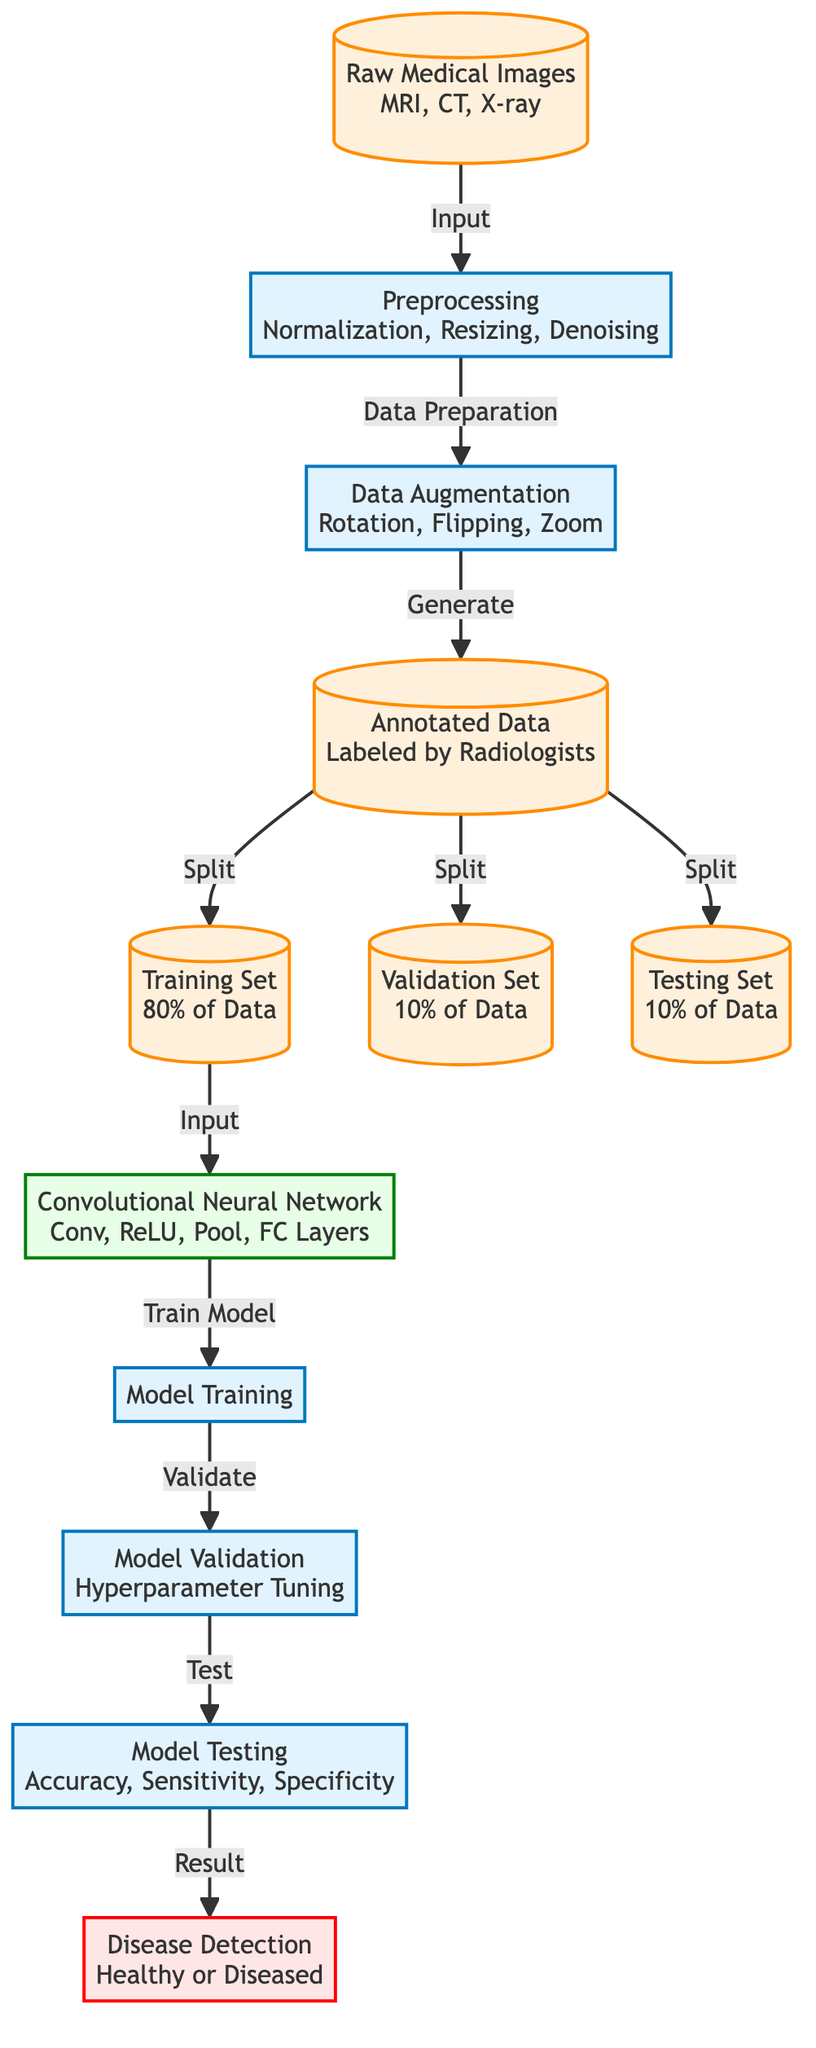What's the total number of nodes in the diagram? By counting each distinct labeled box in the diagram, there are a total of 12 nodes representing different processes and data types.
Answer: 12 What follows "Preprocessing" in the diagram? The process that follows "Preprocessing" is "Data Augmentation", which is indicated by the directed arrow leading from "Preprocessing" to "Data Augmentation".
Answer: Data Augmentation What is the training set percentage in the data split? The "Training Set" is identified in the diagram with a specific node stating it contains 80% of the data.
Answer: 80% Which model architecture is used in this analysis? The model architecture used is a "Convolutional Neural Network," as indicated in the node labeled "Convolutional Neural Network" in the diagram.
Answer: Convolutional Neural Network What are the three performance metrics used in the model testing? The three performance metrics identified in the "Model Testing" node are "Accuracy," "Sensitivity," and "Specificity," as listed in the corresponding node.
Answer: Accuracy, Sensitivity, Specificity How does the diagram split the annotated data? The diagram indicates that the "Annotated Data" is split into "Training Set," "Validation Set," and "Testing Set," as shown by the arrows leading from the "Annotated Data" node to these three distinct nodes.
Answer: Into three sets What is the final output of the diagram? The ultimate output of the process as illustrated in the diagram is "Disease Detection," which concludes the flow after the "Model Testing" node.
Answer: Disease Detection Which step involves hyperparameter tuning? The step involving "hyperparameter tuning" is represented by the "Model Validation" node, which follows the "Model Training" in the diagram.
Answer: Model Validation How is the data prepared before model training? Data preparation before model training involves the "Preprocessing" step that includes "Normalization," "Resizing," and "Denoising," as indicated in the diagram.
Answer: Preprocessing What is the role of data augmentation in this process? The "Data Augmentation" step is responsible for generating more annotated data by applying transformations like "Rotation," "Flipping," and "Zoom," aiding in improving model performance.
Answer: Generating more data 